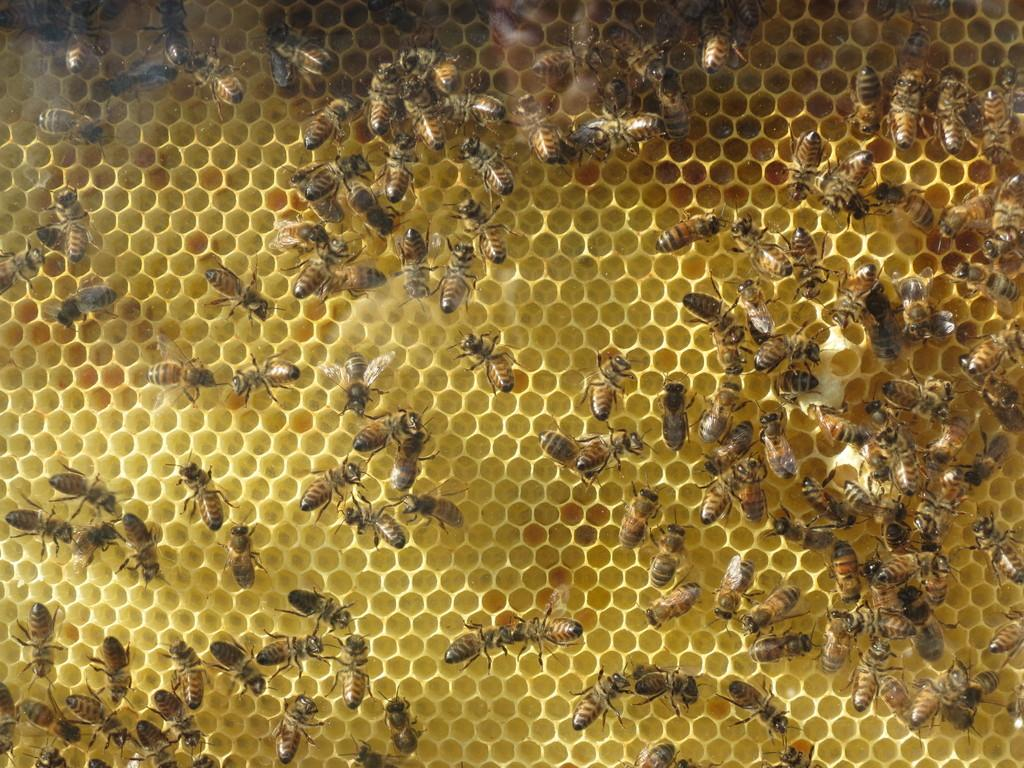What type of creatures can be seen in the image? There are insects in the image. Where are the insects located? The insects are on a beehive. What arithmetic problem is the insect solving on the beehive? There is no arithmetic problem present in the image, as it features insects on a beehive. Can you see the thumb of the person who took the picture in the image? There is no thumb visible in the image, as it focuses on the insects and the beehive. 